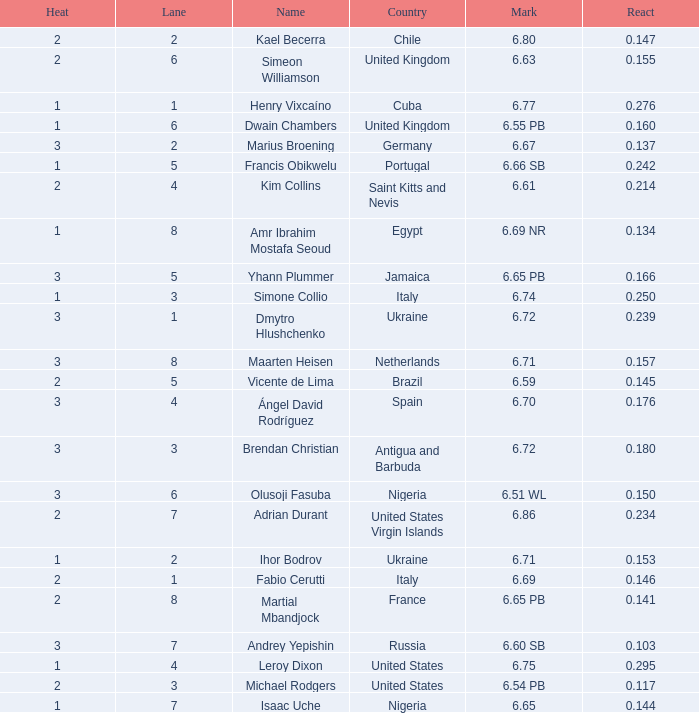Write the full table. {'header': ['Heat', 'Lane', 'Name', 'Country', 'Mark', 'React'], 'rows': [['2', '2', 'Kael Becerra', 'Chile', '6.80', '0.147'], ['2', '6', 'Simeon Williamson', 'United Kingdom', '6.63', '0.155'], ['1', '1', 'Henry Vixcaíno', 'Cuba', '6.77', '0.276'], ['1', '6', 'Dwain Chambers', 'United Kingdom', '6.55 PB', '0.160'], ['3', '2', 'Marius Broening', 'Germany', '6.67', '0.137'], ['1', '5', 'Francis Obikwelu', 'Portugal', '6.66 SB', '0.242'], ['2', '4', 'Kim Collins', 'Saint Kitts and Nevis', '6.61', '0.214'], ['1', '8', 'Amr Ibrahim Mostafa Seoud', 'Egypt', '6.69 NR', '0.134'], ['3', '5', 'Yhann Plummer', 'Jamaica', '6.65 PB', '0.166'], ['1', '3', 'Simone Collio', 'Italy', '6.74', '0.250'], ['3', '1', 'Dmytro Hlushchenko', 'Ukraine', '6.72', '0.239'], ['3', '8', 'Maarten Heisen', 'Netherlands', '6.71', '0.157'], ['2', '5', 'Vicente de Lima', 'Brazil', '6.59', '0.145'], ['3', '4', 'Ángel David Rodríguez', 'Spain', '6.70', '0.176'], ['3', '3', 'Brendan Christian', 'Antigua and Barbuda', '6.72', '0.180'], ['3', '6', 'Olusoji Fasuba', 'Nigeria', '6.51 WL', '0.150'], ['2', '7', 'Adrian Durant', 'United States Virgin Islands', '6.86', '0.234'], ['1', '2', 'Ihor Bodrov', 'Ukraine', '6.71', '0.153'], ['2', '1', 'Fabio Cerutti', 'Italy', '6.69', '0.146'], ['2', '8', 'Martial Mbandjock', 'France', '6.65 PB', '0.141'], ['3', '7', 'Andrey Yepishin', 'Russia', '6.60 SB', '0.103'], ['1', '4', 'Leroy Dixon', 'United States', '6.75', '0.295'], ['2', '3', 'Michael Rodgers', 'United States', '6.54 PB', '0.117'], ['1', '7', 'Isaac Uche', 'Nigeria', '6.65', '0.144']]} What is Country, when Lane is 5, and when React is greater than 0.166? Portugal. 